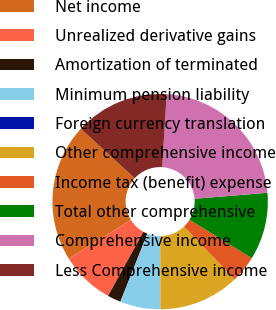Convert chart to OTSL. <chart><loc_0><loc_0><loc_500><loc_500><pie_chart><fcel>Net income<fcel>Unrealized derivative gains<fcel>Amortization of terminated<fcel>Minimum pension liability<fcel>Foreign currency translation<fcel>Other comprehensive income<fcel>Income tax (benefit) expense<fcel>Total other comprehensive<fcel>Comprehensive income<fcel>Less Comprehensive income<nl><fcel>20.7%<fcel>8.08%<fcel>2.02%<fcel>6.06%<fcel>0.0%<fcel>12.12%<fcel>4.04%<fcel>10.1%<fcel>22.72%<fcel>14.14%<nl></chart> 